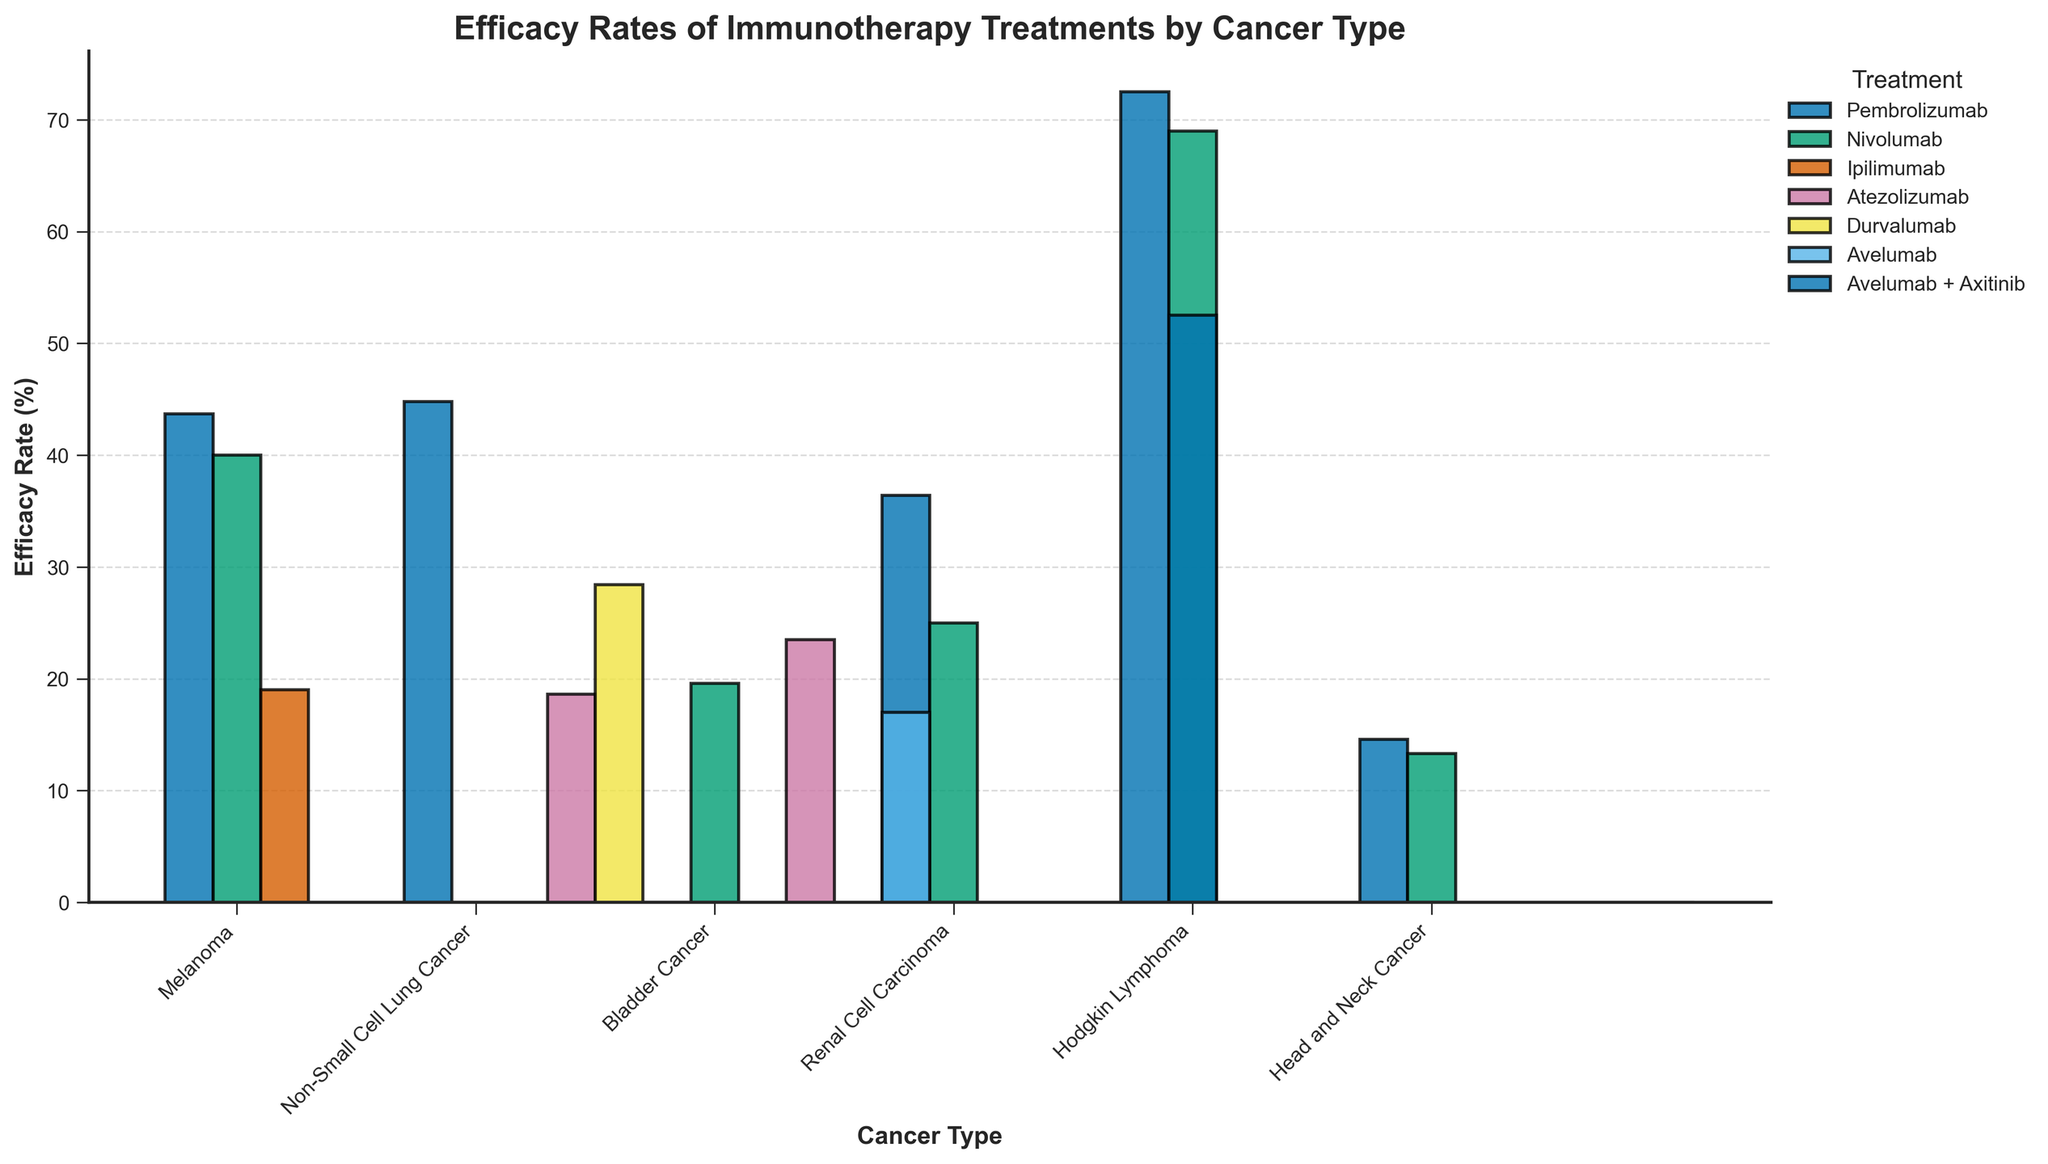What's the efficacy rate of Pembrolizumab for Non-Small Cell Lung Cancer? Look at the bar for Pembrolizumab under the Non-Small Cell Lung Cancer category. The height indicates an efficacy rate of 44.8%.
Answer: 44.8% Which treatment shows the highest efficacy rate for Hodgkin Lymphoma? Identify the bars under Hodgkin Lymphoma and find the one with the maximum height. Pembrolizumab has the highest bar, indicating an efficacy rate of 72.5%.
Answer: Pembrolizumab How do the efficacy rates of Nivolumab compare between Melanoma and Non-Small Cell Lung Cancer? Compare the heights of the bars for Nivolumab under Melanoma and Non-Small Cell Lung Cancer. Melanoma has an efficacy rate of 40.0%, and Non-Small Cell Lung Cancer has 28.4%.
Answer: Melanoma has a higher efficacy rate What is the average efficacy rate of treatments for Bladder Cancer? Sum the efficacy rates for Bladder Cancer (23.5 + 19.6 + 17.0 = 60.1) and divide by the number of treatments (3). The average is 60.1/3 = 20.03%.
Answer: 20.03% Which cancer type has the most varied efficacy rates, considering the difference between the highest and lowest values? Look at the range for each cancer type. Melanoma ranges from 19.0% to 43.7%, Non-Small Cell Lung Cancer from 18.6% to 44.8%, Bladder Cancer from 17.0% to 23.5%, Renal Cell Carcinoma from 25.0% to 52.5%, Hodgkin Lymphoma from 69.0% to 72.5%, and Head and Neck Cancer from 13.3% to 14.6%. The most varied is Renal Cell Carcinoma (52.5% - 25.0% = 27.5%).
Answer: Renal Cell Carcinoma What's the difference between the efficacy rates of the most and least effective treatments for Melanoma? For Melanoma, the efficacy rates are 43.7% (Pembrolizumab), 40.0% (Nivolumab), and 19.0% (Ipilimumab). The difference between the highest and lowest is 43.7% - 19.0% = 24.7%.
Answer: 24.7% Which treatment has a closer efficacy rate to 50% for Renal Cell Carcinoma? Examine the bars for Renal Cell Carcinoma. Pembrolizumab has 36.4% and Avelumab + Axitinib has 52.5%. 52.5% is closer to 50% than 36.4%.
Answer: Avelumab + Axitinib What is the combined efficacy rate of Pembrolizumab treatments across all cancer types? Sum the efficacy rates for Pembrolizumab: 43.7% (Melanoma), 44.8% (Non-Small Cell Lung Cancer), 36.4% (Renal Cell Carcinoma), 72.5% (Hodgkin Lymphoma), and 14.6% (Head and Neck Cancer). The total combined rate is 43.7 + 44.8 + 36.4 + 72.5 + 14.6 = 212%.
Answer: 212% What's the average efficacy rate of all treatments shown in the figure? Sum all efficacy rates: 43.7 + 40.0 + 19.0 + 18.6 + 28.4 + 44.8 + 23.5 + 19.6 + 17.0 + 25.0 + 36.4 + 52.5 + 69.0 + 72.5 + 14.6 + 13.3 = 538.9 and divide by the total number of treatments (16). The average is 538.9/16 ≈ 33.68%.
Answer: 33.68% Which treatment has the lowest efficacy rate across all cancer types? Identify the shortest bar in the figure, which corresponds to Head and Neck Cancer treated with Nivolumab, with an efficacy rate of 13.3%.
Answer: Nivolumab for Head and Neck Cancer 